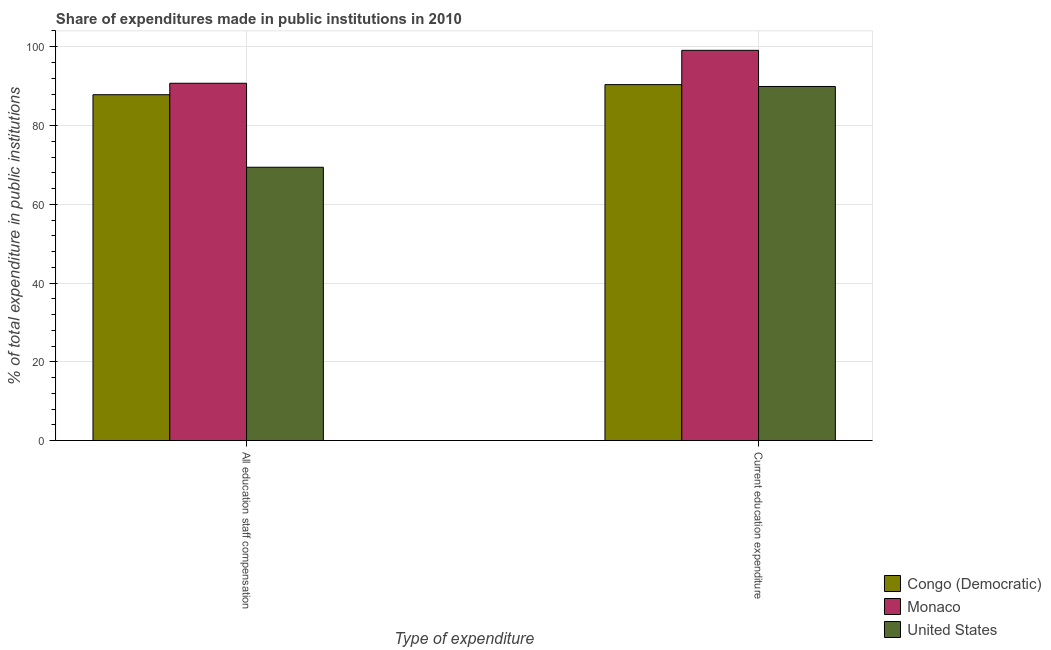What is the label of the 1st group of bars from the left?
Offer a very short reply. All education staff compensation. What is the expenditure in staff compensation in United States?
Ensure brevity in your answer.  69.4. Across all countries, what is the maximum expenditure in education?
Offer a very short reply. 99.09. Across all countries, what is the minimum expenditure in staff compensation?
Provide a succinct answer. 69.4. In which country was the expenditure in education maximum?
Offer a very short reply. Monaco. What is the total expenditure in staff compensation in the graph?
Provide a succinct answer. 247.96. What is the difference between the expenditure in staff compensation in Monaco and that in United States?
Keep it short and to the point. 21.33. What is the difference between the expenditure in staff compensation in Congo (Democratic) and the expenditure in education in United States?
Provide a succinct answer. -2.09. What is the average expenditure in staff compensation per country?
Provide a succinct answer. 82.65. What is the difference between the expenditure in education and expenditure in staff compensation in United States?
Provide a short and direct response. 20.51. What is the ratio of the expenditure in staff compensation in Monaco to that in United States?
Your response must be concise. 1.31. What does the 1st bar from the left in Current education expenditure represents?
Offer a very short reply. Congo (Democratic). What does the 3rd bar from the right in All education staff compensation represents?
Make the answer very short. Congo (Democratic). Are all the bars in the graph horizontal?
Keep it short and to the point. No. How many countries are there in the graph?
Ensure brevity in your answer.  3. What is the difference between two consecutive major ticks on the Y-axis?
Provide a short and direct response. 20. Are the values on the major ticks of Y-axis written in scientific E-notation?
Give a very brief answer. No. Does the graph contain grids?
Your answer should be very brief. Yes. How are the legend labels stacked?
Make the answer very short. Vertical. What is the title of the graph?
Give a very brief answer. Share of expenditures made in public institutions in 2010. Does "Sierra Leone" appear as one of the legend labels in the graph?
Offer a terse response. No. What is the label or title of the X-axis?
Offer a terse response. Type of expenditure. What is the label or title of the Y-axis?
Offer a very short reply. % of total expenditure in public institutions. What is the % of total expenditure in public institutions in Congo (Democratic) in All education staff compensation?
Make the answer very short. 87.82. What is the % of total expenditure in public institutions in Monaco in All education staff compensation?
Offer a terse response. 90.73. What is the % of total expenditure in public institutions in United States in All education staff compensation?
Keep it short and to the point. 69.4. What is the % of total expenditure in public institutions of Congo (Democratic) in Current education expenditure?
Your answer should be compact. 90.38. What is the % of total expenditure in public institutions in Monaco in Current education expenditure?
Your response must be concise. 99.09. What is the % of total expenditure in public institutions in United States in Current education expenditure?
Provide a succinct answer. 89.91. Across all Type of expenditure, what is the maximum % of total expenditure in public institutions in Congo (Democratic)?
Offer a terse response. 90.38. Across all Type of expenditure, what is the maximum % of total expenditure in public institutions of Monaco?
Your answer should be compact. 99.09. Across all Type of expenditure, what is the maximum % of total expenditure in public institutions in United States?
Give a very brief answer. 89.91. Across all Type of expenditure, what is the minimum % of total expenditure in public institutions in Congo (Democratic)?
Make the answer very short. 87.82. Across all Type of expenditure, what is the minimum % of total expenditure in public institutions in Monaco?
Keep it short and to the point. 90.73. Across all Type of expenditure, what is the minimum % of total expenditure in public institutions of United States?
Your answer should be compact. 69.4. What is the total % of total expenditure in public institutions of Congo (Democratic) in the graph?
Provide a succinct answer. 178.21. What is the total % of total expenditure in public institutions in Monaco in the graph?
Offer a terse response. 189.82. What is the total % of total expenditure in public institutions in United States in the graph?
Ensure brevity in your answer.  159.32. What is the difference between the % of total expenditure in public institutions of Congo (Democratic) in All education staff compensation and that in Current education expenditure?
Provide a short and direct response. -2.56. What is the difference between the % of total expenditure in public institutions in Monaco in All education staff compensation and that in Current education expenditure?
Your answer should be very brief. -8.36. What is the difference between the % of total expenditure in public institutions in United States in All education staff compensation and that in Current education expenditure?
Keep it short and to the point. -20.51. What is the difference between the % of total expenditure in public institutions of Congo (Democratic) in All education staff compensation and the % of total expenditure in public institutions of Monaco in Current education expenditure?
Provide a succinct answer. -11.27. What is the difference between the % of total expenditure in public institutions in Congo (Democratic) in All education staff compensation and the % of total expenditure in public institutions in United States in Current education expenditure?
Offer a very short reply. -2.09. What is the difference between the % of total expenditure in public institutions of Monaco in All education staff compensation and the % of total expenditure in public institutions of United States in Current education expenditure?
Your response must be concise. 0.82. What is the average % of total expenditure in public institutions of Congo (Democratic) per Type of expenditure?
Your answer should be compact. 89.1. What is the average % of total expenditure in public institutions of Monaco per Type of expenditure?
Your answer should be very brief. 94.91. What is the average % of total expenditure in public institutions of United States per Type of expenditure?
Keep it short and to the point. 79.66. What is the difference between the % of total expenditure in public institutions of Congo (Democratic) and % of total expenditure in public institutions of Monaco in All education staff compensation?
Keep it short and to the point. -2.91. What is the difference between the % of total expenditure in public institutions of Congo (Democratic) and % of total expenditure in public institutions of United States in All education staff compensation?
Offer a very short reply. 18.42. What is the difference between the % of total expenditure in public institutions in Monaco and % of total expenditure in public institutions in United States in All education staff compensation?
Make the answer very short. 21.33. What is the difference between the % of total expenditure in public institutions of Congo (Democratic) and % of total expenditure in public institutions of Monaco in Current education expenditure?
Your answer should be very brief. -8.7. What is the difference between the % of total expenditure in public institutions in Congo (Democratic) and % of total expenditure in public institutions in United States in Current education expenditure?
Offer a very short reply. 0.47. What is the difference between the % of total expenditure in public institutions in Monaco and % of total expenditure in public institutions in United States in Current education expenditure?
Make the answer very short. 9.18. What is the ratio of the % of total expenditure in public institutions of Congo (Democratic) in All education staff compensation to that in Current education expenditure?
Keep it short and to the point. 0.97. What is the ratio of the % of total expenditure in public institutions of Monaco in All education staff compensation to that in Current education expenditure?
Your answer should be very brief. 0.92. What is the ratio of the % of total expenditure in public institutions in United States in All education staff compensation to that in Current education expenditure?
Ensure brevity in your answer.  0.77. What is the difference between the highest and the second highest % of total expenditure in public institutions of Congo (Democratic)?
Provide a succinct answer. 2.56. What is the difference between the highest and the second highest % of total expenditure in public institutions in Monaco?
Your answer should be very brief. 8.36. What is the difference between the highest and the second highest % of total expenditure in public institutions in United States?
Your answer should be compact. 20.51. What is the difference between the highest and the lowest % of total expenditure in public institutions of Congo (Democratic)?
Ensure brevity in your answer.  2.56. What is the difference between the highest and the lowest % of total expenditure in public institutions of Monaco?
Provide a short and direct response. 8.36. What is the difference between the highest and the lowest % of total expenditure in public institutions in United States?
Provide a short and direct response. 20.51. 